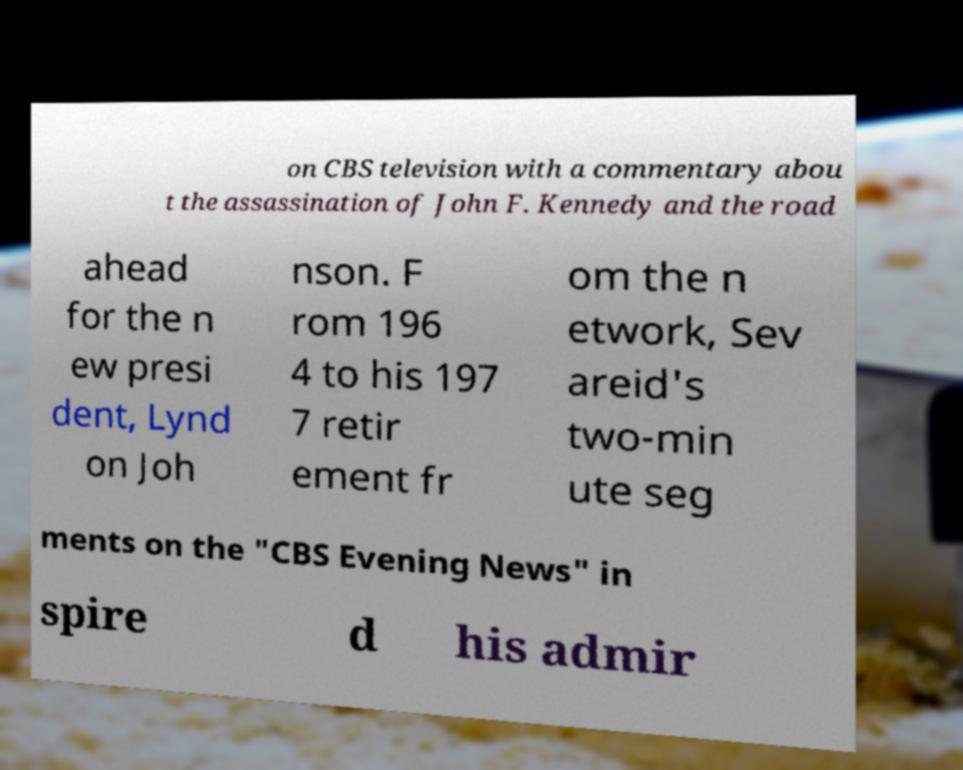I need the written content from this picture converted into text. Can you do that? on CBS television with a commentary abou t the assassination of John F. Kennedy and the road ahead for the n ew presi dent, Lynd on Joh nson. F rom 196 4 to his 197 7 retir ement fr om the n etwork, Sev areid's two-min ute seg ments on the "CBS Evening News" in spire d his admir 